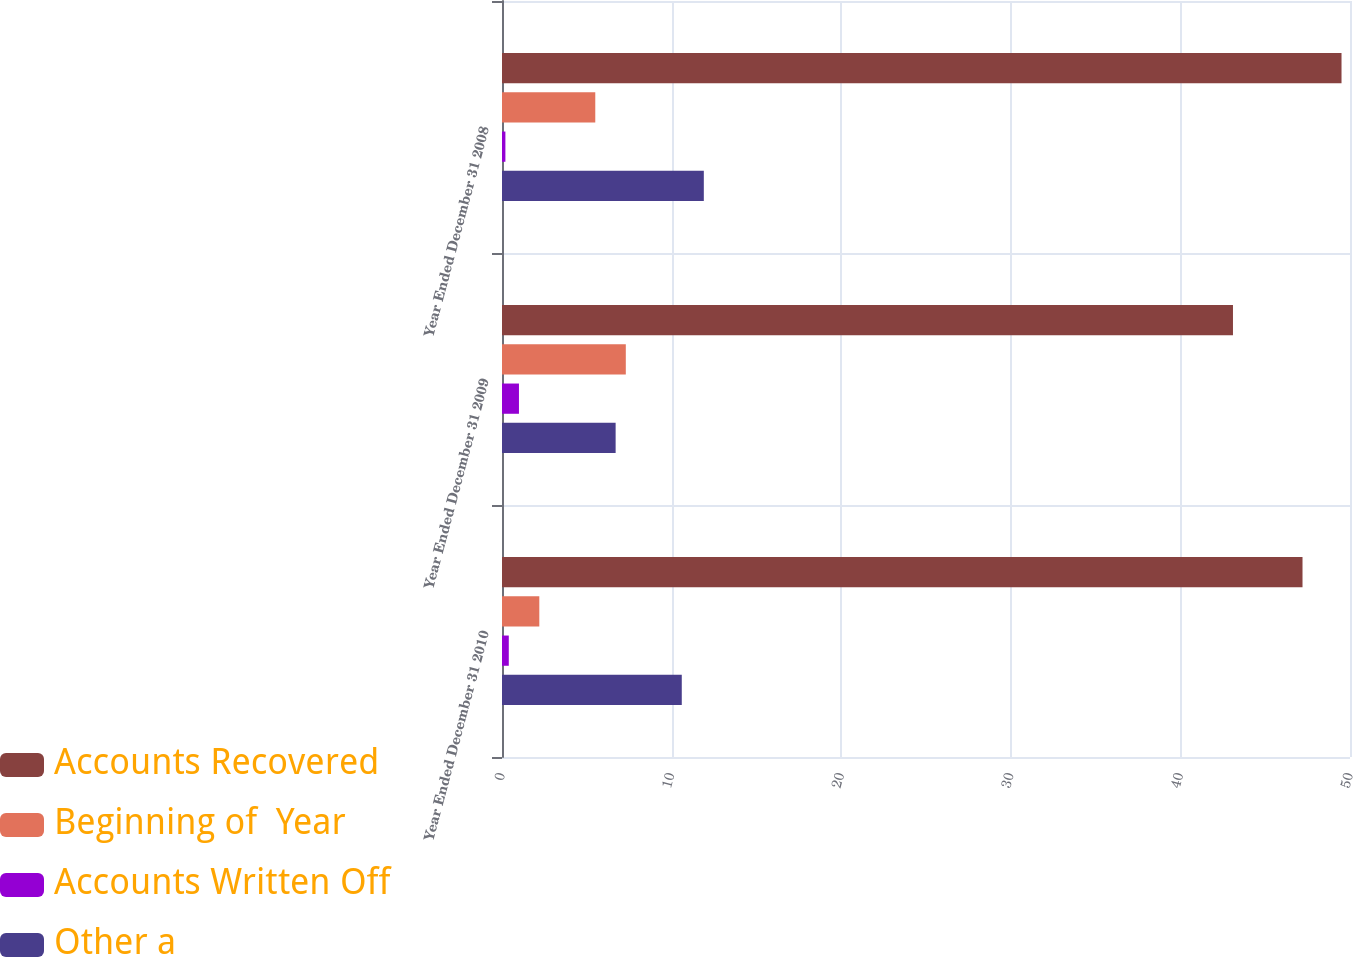<chart> <loc_0><loc_0><loc_500><loc_500><stacked_bar_chart><ecel><fcel>Year Ended December 31 2010<fcel>Year Ended December 31 2009<fcel>Year Ended December 31 2008<nl><fcel>Accounts Recovered<fcel>47.2<fcel>43.1<fcel>49.5<nl><fcel>Beginning of  Year<fcel>2.2<fcel>7.3<fcel>5.5<nl><fcel>Accounts Written Off<fcel>0.4<fcel>1<fcel>0.2<nl><fcel>Other a<fcel>10.6<fcel>6.7<fcel>11.9<nl></chart> 